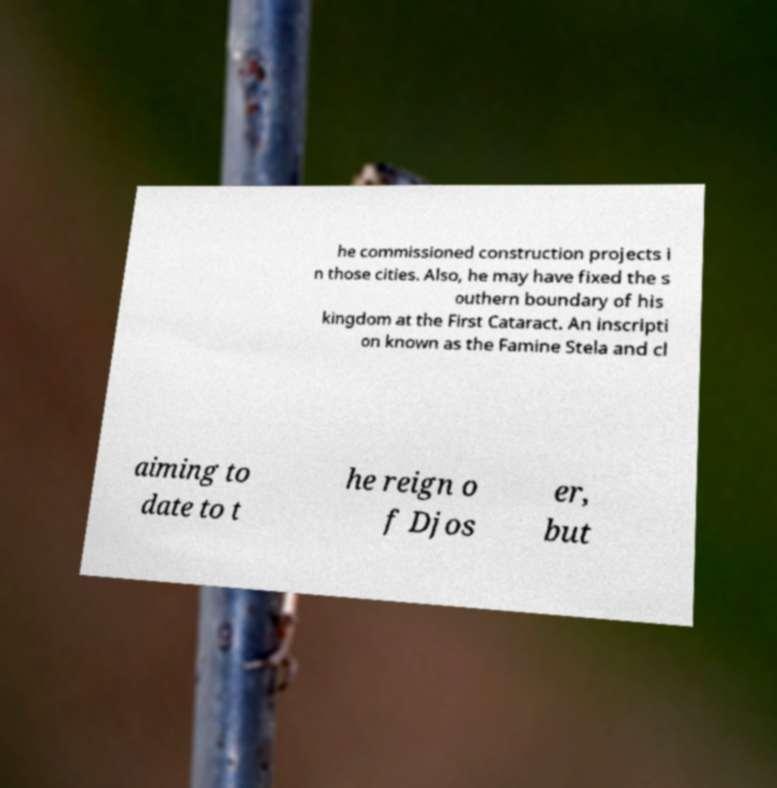Please read and relay the text visible in this image. What does it say? he commissioned construction projects i n those cities. Also, he may have fixed the s outhern boundary of his kingdom at the First Cataract. An inscripti on known as the Famine Stela and cl aiming to date to t he reign o f Djos er, but 